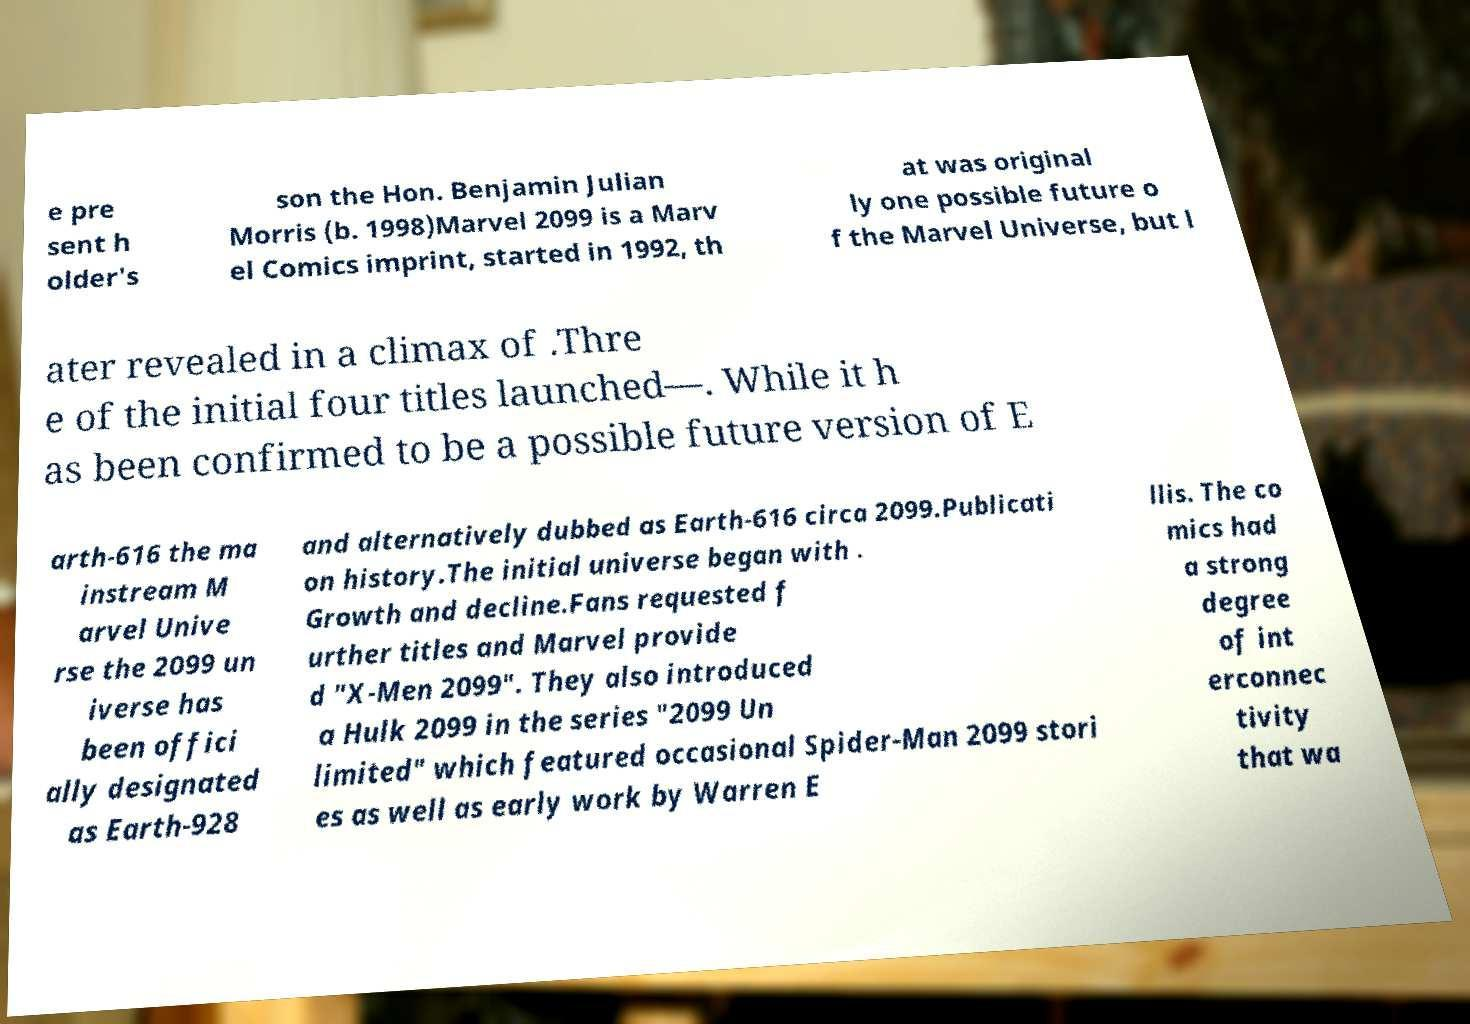I need the written content from this picture converted into text. Can you do that? e pre sent h older's son the Hon. Benjamin Julian Morris (b. 1998)Marvel 2099 is a Marv el Comics imprint, started in 1992, th at was original ly one possible future o f the Marvel Universe, but l ater revealed in a climax of .Thre e of the initial four titles launched—. While it h as been confirmed to be a possible future version of E arth-616 the ma instream M arvel Unive rse the 2099 un iverse has been offici ally designated as Earth-928 and alternatively dubbed as Earth-616 circa 2099.Publicati on history.The initial universe began with . Growth and decline.Fans requested f urther titles and Marvel provide d "X-Men 2099". They also introduced a Hulk 2099 in the series "2099 Un limited" which featured occasional Spider-Man 2099 stori es as well as early work by Warren E llis. The co mics had a strong degree of int erconnec tivity that wa 